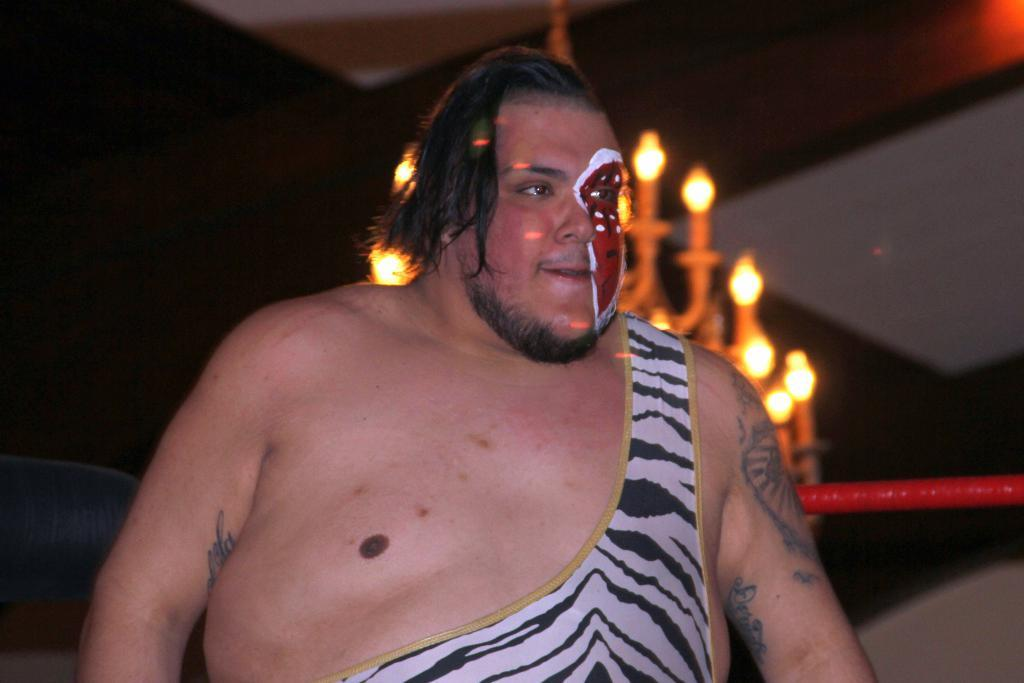What is present in the image? There is a person in the image. What can be observed about the person's appearance? The person has a painting on their body and face. What can be seen in the background of the image? There is a chandelier in the background of the image. How is the background of the image depicted? The background of the image is blurred. How many legs does the shop have in the image? There is no shop present in the image, so it is not possible to determine the number of legs it might have. 